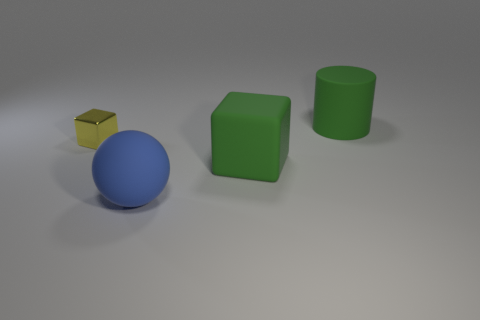Add 3 small cyan metallic cylinders. How many objects exist? 7 Subtract all cylinders. How many objects are left? 3 Add 1 big cubes. How many big cubes are left? 2 Add 4 green rubber cylinders. How many green rubber cylinders exist? 5 Subtract 0 brown blocks. How many objects are left? 4 Subtract all purple cylinders. Subtract all blue things. How many objects are left? 3 